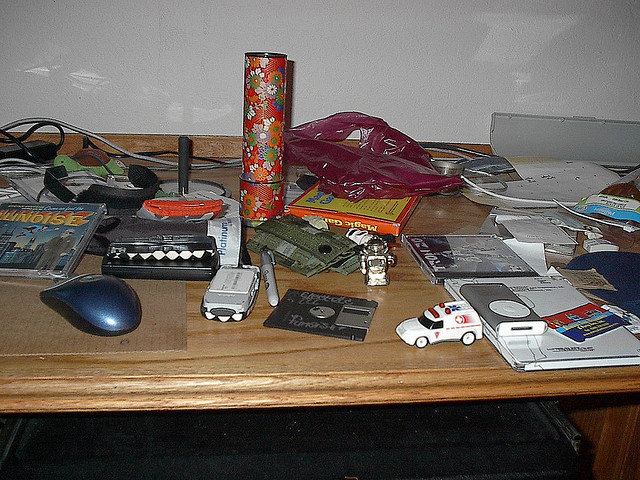Please transcribe the text in this image. Platinum LINOISE 